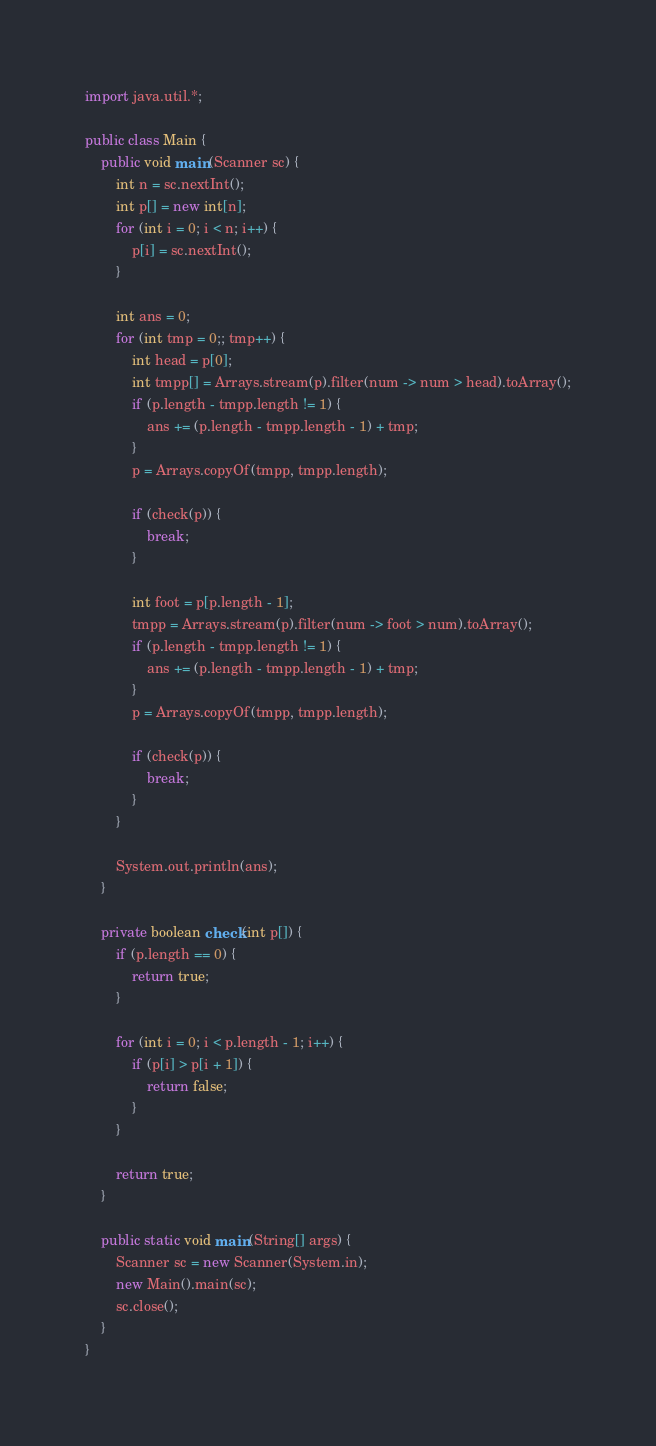Convert code to text. <code><loc_0><loc_0><loc_500><loc_500><_Java_>import java.util.*;

public class Main {
    public void main(Scanner sc) {
        int n = sc.nextInt();
        int p[] = new int[n];
        for (int i = 0; i < n; i++) {
            p[i] = sc.nextInt();
        }

        int ans = 0;
        for (int tmp = 0;; tmp++) {
            int head = p[0];
            int tmpp[] = Arrays.stream(p).filter(num -> num > head).toArray();
            if (p.length - tmpp.length != 1) {
                ans += (p.length - tmpp.length - 1) + tmp;
            }
            p = Arrays.copyOf(tmpp, tmpp.length);

            if (check(p)) {
                break;
            }

            int foot = p[p.length - 1];
            tmpp = Arrays.stream(p).filter(num -> foot > num).toArray();
            if (p.length - tmpp.length != 1) {
                ans += (p.length - tmpp.length - 1) + tmp;
            }
            p = Arrays.copyOf(tmpp, tmpp.length);

            if (check(p)) {
                break;
            }
        }

        System.out.println(ans);
    }

    private boolean check(int p[]) {
        if (p.length == 0) {
            return true;
        }

        for (int i = 0; i < p.length - 1; i++) {
            if (p[i] > p[i + 1]) {
                return false;
            }
        }

        return true;
    }

    public static void main(String[] args) {
        Scanner sc = new Scanner(System.in);
        new Main().main(sc);
        sc.close();
    }
}
</code> 